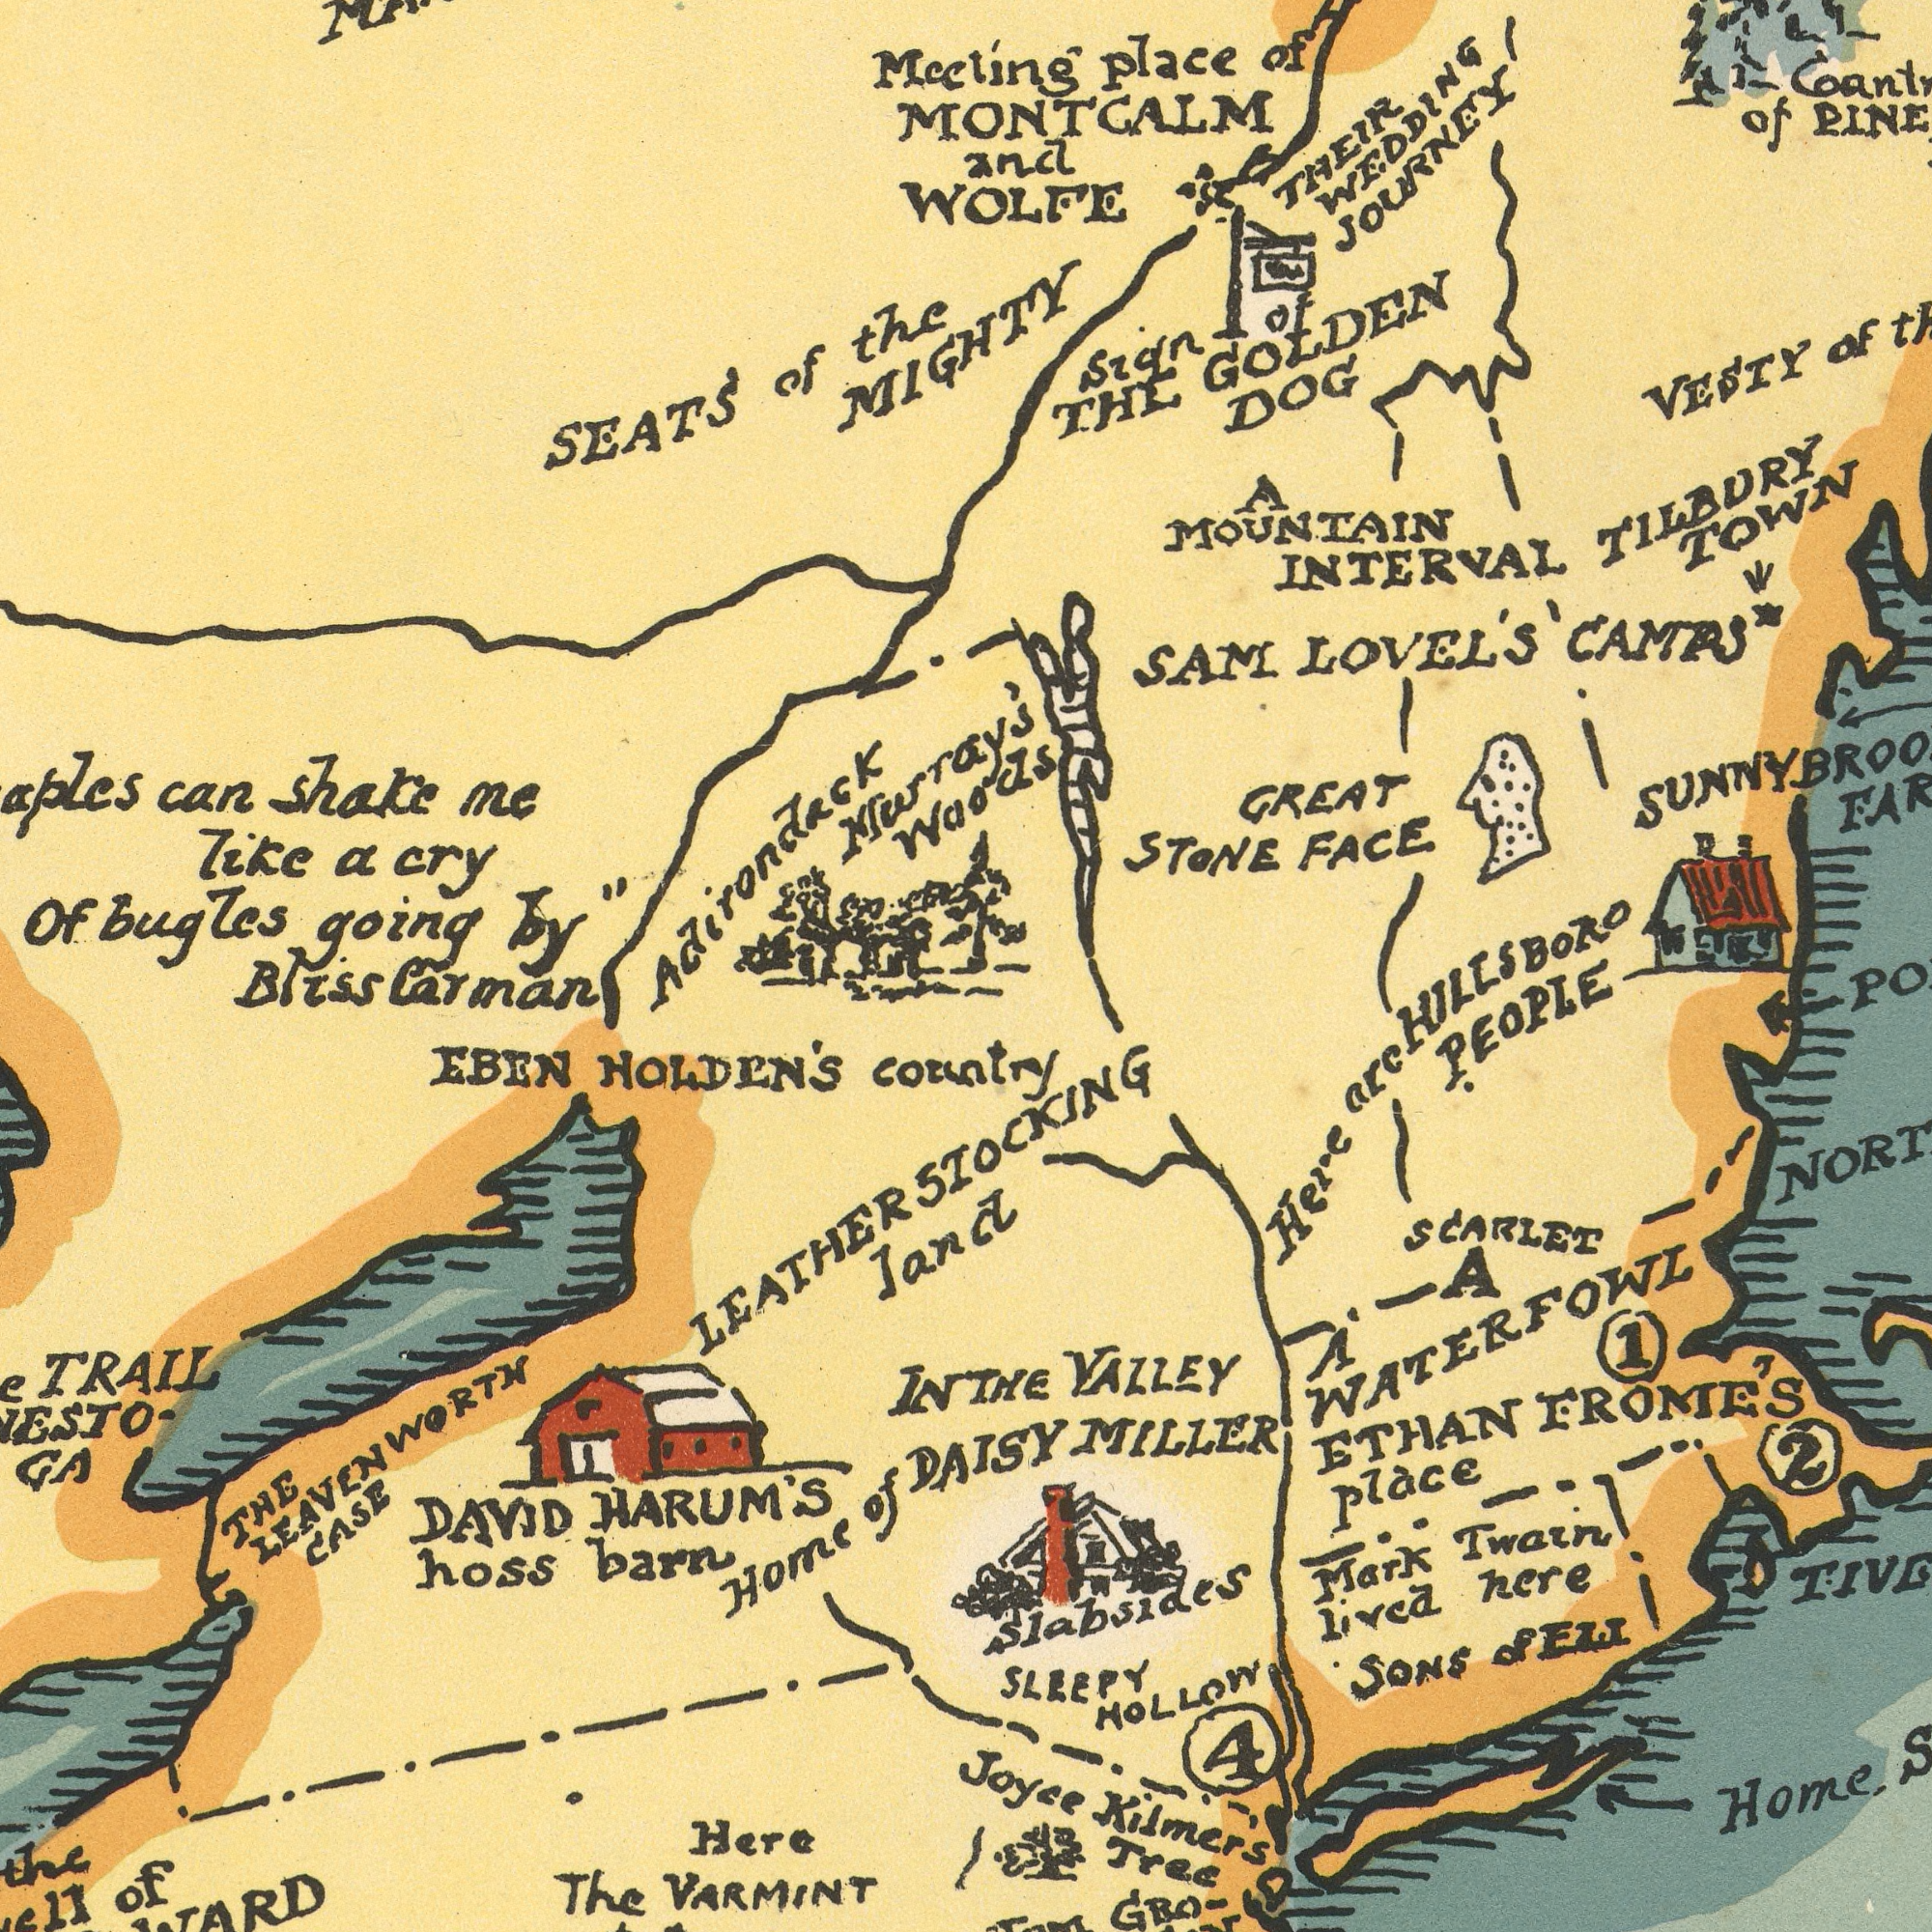What text appears in the top-right area of the image? MIGHTY GREAT FACE VESTY DOG STONE LOVEL'S THE Sign TOWN INTERVAL THEIR MOUNTAIN CAMPS JOURNEY of GOLDEN WEDDING SAM TILBURY Meeting place of MONTCALM and WOLFE of of A Waods HILLSBORO What text appears in the bottom-right area of the image? country Here FROME'S ETHAN VALLEY SONS Tree Joyce Mark lived STOCKING Kilmer's THE plàce here PEOPLE SLEEPY A HOLLOW A Home Twain arc SCARLET WATERFOWL GRo- land DAISY MILLER 1 2 4 Slabsides of ELL What text is visible in the lower-left corner? hoss EBEN Here HOLDEN'S Bliss barn DAVID Home IN TRAIL GA Carman HARUM'S VARMINT The of LEATHERS THE LEAVENWORTH CASE the of What text is shown in the top-left quadrant? like Of shake can going me the of a bugles cry Murray's Adirondack SEATS by" 